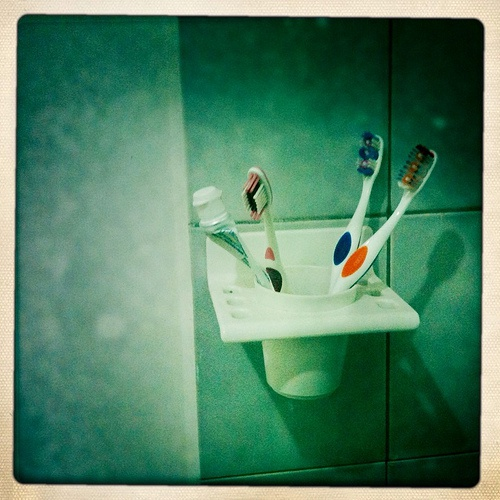Describe the objects in this image and their specific colors. I can see cup in beige, lightgreen, green, and darkgreen tones, toothbrush in beige, aquamarine, black, and darkgreen tones, toothbrush in beige, darkblue, and teal tones, toothbrush in beige, lightgreen, black, and tan tones, and toothbrush in beige, lightgreen, green, and turquoise tones in this image. 